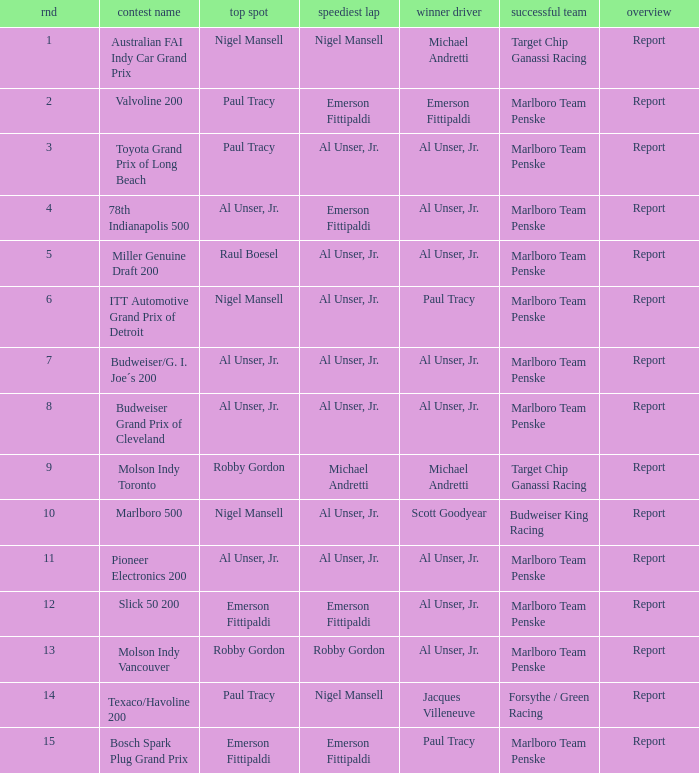What's the report of the race won by Michael Andretti, with Nigel Mansell driving the fastest lap? Report. 